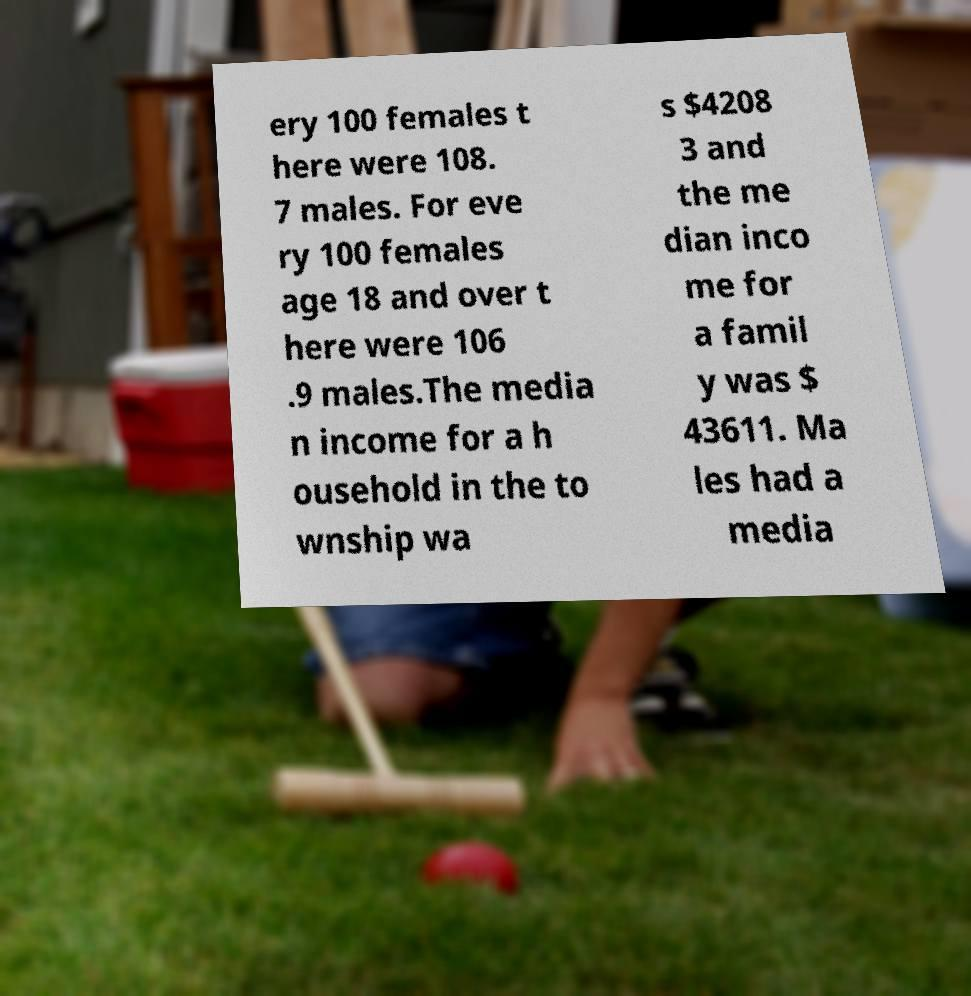Can you read and provide the text displayed in the image?This photo seems to have some interesting text. Can you extract and type it out for me? ery 100 females t here were 108. 7 males. For eve ry 100 females age 18 and over t here were 106 .9 males.The media n income for a h ousehold in the to wnship wa s $4208 3 and the me dian inco me for a famil y was $ 43611. Ma les had a media 